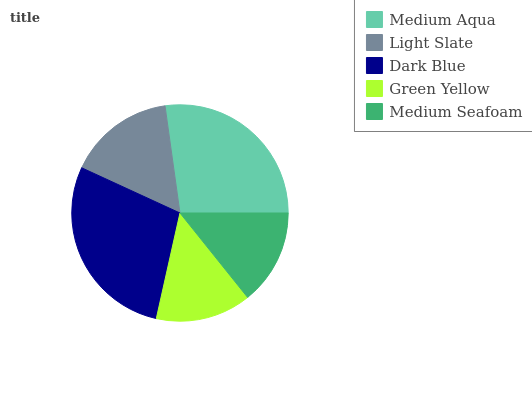Is Medium Seafoam the minimum?
Answer yes or no. Yes. Is Dark Blue the maximum?
Answer yes or no. Yes. Is Light Slate the minimum?
Answer yes or no. No. Is Light Slate the maximum?
Answer yes or no. No. Is Medium Aqua greater than Light Slate?
Answer yes or no. Yes. Is Light Slate less than Medium Aqua?
Answer yes or no. Yes. Is Light Slate greater than Medium Aqua?
Answer yes or no. No. Is Medium Aqua less than Light Slate?
Answer yes or no. No. Is Light Slate the high median?
Answer yes or no. Yes. Is Light Slate the low median?
Answer yes or no. Yes. Is Medium Seafoam the high median?
Answer yes or no. No. Is Green Yellow the low median?
Answer yes or no. No. 